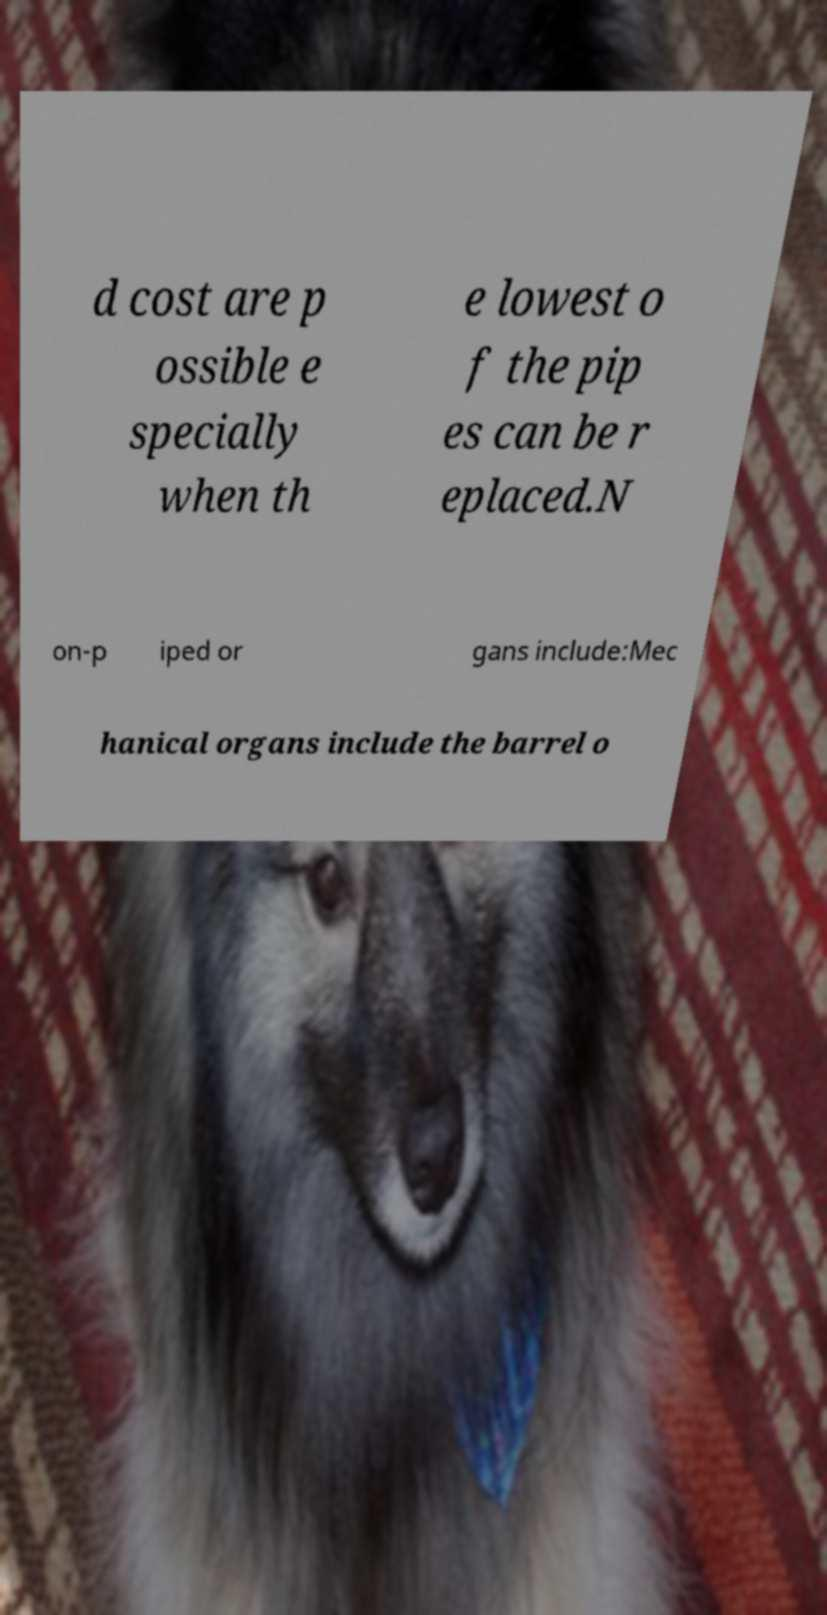Could you assist in decoding the text presented in this image and type it out clearly? d cost are p ossible e specially when th e lowest o f the pip es can be r eplaced.N on-p iped or gans include:Mec hanical organs include the barrel o 